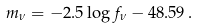Convert formula to latex. <formula><loc_0><loc_0><loc_500><loc_500>m _ { \nu } = - 2 . 5 \log f _ { \nu } - 4 8 . 5 9 \, .</formula> 